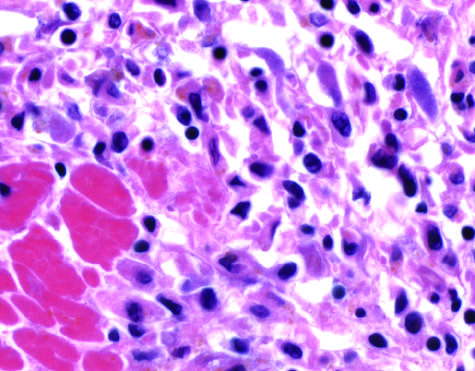what show an inflammatory reaction in the myocardium after ischemic necrosis infarction?
Answer the question using a single word or phrase. The photomicrographs 